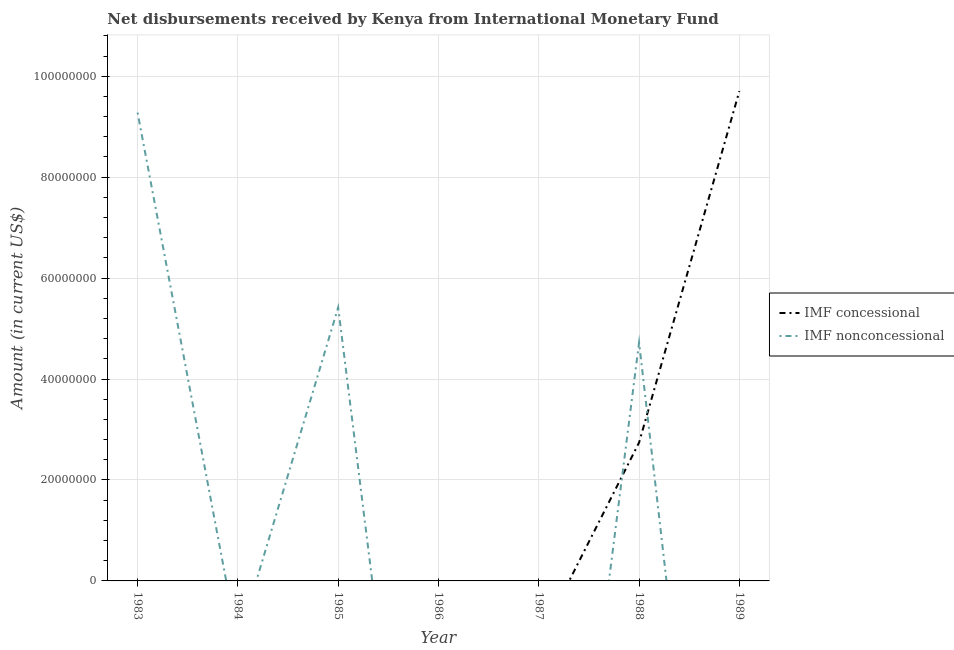What is the net concessional disbursements from imf in 1989?
Give a very brief answer. 9.71e+07. Across all years, what is the maximum net non concessional disbursements from imf?
Your answer should be compact. 9.28e+07. Across all years, what is the minimum net concessional disbursements from imf?
Provide a short and direct response. 0. What is the total net concessional disbursements from imf in the graph?
Make the answer very short. 1.24e+08. What is the difference between the net concessional disbursements from imf in 1988 and that in 1989?
Ensure brevity in your answer.  -6.96e+07. What is the difference between the net non concessional disbursements from imf in 1987 and the net concessional disbursements from imf in 1985?
Offer a terse response. 0. What is the average net concessional disbursements from imf per year?
Provide a succinct answer. 1.78e+07. In how many years, is the net concessional disbursements from imf greater than 60000000 US$?
Give a very brief answer. 1. What is the ratio of the net non concessional disbursements from imf in 1985 to that in 1988?
Offer a very short reply. 1.15. What is the difference between the highest and the second highest net non concessional disbursements from imf?
Provide a succinct answer. 3.86e+07. What is the difference between the highest and the lowest net non concessional disbursements from imf?
Ensure brevity in your answer.  9.28e+07. In how many years, is the net non concessional disbursements from imf greater than the average net non concessional disbursements from imf taken over all years?
Provide a short and direct response. 3. Is the net non concessional disbursements from imf strictly greater than the net concessional disbursements from imf over the years?
Make the answer very short. No. What is the difference between two consecutive major ticks on the Y-axis?
Your answer should be very brief. 2.00e+07. Are the values on the major ticks of Y-axis written in scientific E-notation?
Offer a terse response. No. Where does the legend appear in the graph?
Your response must be concise. Center right. How are the legend labels stacked?
Give a very brief answer. Vertical. What is the title of the graph?
Provide a succinct answer. Net disbursements received by Kenya from International Monetary Fund. What is the label or title of the Y-axis?
Keep it short and to the point. Amount (in current US$). What is the Amount (in current US$) of IMF nonconcessional in 1983?
Offer a very short reply. 9.28e+07. What is the Amount (in current US$) of IMF concessional in 1984?
Provide a succinct answer. 0. What is the Amount (in current US$) in IMF nonconcessional in 1984?
Keep it short and to the point. 0. What is the Amount (in current US$) of IMF nonconcessional in 1985?
Keep it short and to the point. 5.42e+07. What is the Amount (in current US$) in IMF nonconcessional in 1986?
Keep it short and to the point. 0. What is the Amount (in current US$) of IMF concessional in 1987?
Provide a succinct answer. 0. What is the Amount (in current US$) of IMF nonconcessional in 1987?
Keep it short and to the point. 0. What is the Amount (in current US$) in IMF concessional in 1988?
Offer a terse response. 2.74e+07. What is the Amount (in current US$) of IMF nonconcessional in 1988?
Give a very brief answer. 4.73e+07. What is the Amount (in current US$) in IMF concessional in 1989?
Give a very brief answer. 9.71e+07. What is the Amount (in current US$) in IMF nonconcessional in 1989?
Your answer should be very brief. 0. Across all years, what is the maximum Amount (in current US$) of IMF concessional?
Your answer should be very brief. 9.71e+07. Across all years, what is the maximum Amount (in current US$) of IMF nonconcessional?
Your response must be concise. 9.28e+07. Across all years, what is the minimum Amount (in current US$) of IMF concessional?
Keep it short and to the point. 0. Across all years, what is the minimum Amount (in current US$) in IMF nonconcessional?
Provide a short and direct response. 0. What is the total Amount (in current US$) in IMF concessional in the graph?
Ensure brevity in your answer.  1.24e+08. What is the total Amount (in current US$) in IMF nonconcessional in the graph?
Your response must be concise. 1.94e+08. What is the difference between the Amount (in current US$) in IMF nonconcessional in 1983 and that in 1985?
Keep it short and to the point. 3.86e+07. What is the difference between the Amount (in current US$) of IMF nonconcessional in 1983 and that in 1988?
Your response must be concise. 4.55e+07. What is the difference between the Amount (in current US$) of IMF nonconcessional in 1985 and that in 1988?
Make the answer very short. 6.94e+06. What is the difference between the Amount (in current US$) of IMF concessional in 1988 and that in 1989?
Offer a terse response. -6.96e+07. What is the average Amount (in current US$) of IMF concessional per year?
Offer a terse response. 1.78e+07. What is the average Amount (in current US$) of IMF nonconcessional per year?
Your response must be concise. 2.78e+07. In the year 1988, what is the difference between the Amount (in current US$) of IMF concessional and Amount (in current US$) of IMF nonconcessional?
Offer a very short reply. -1.98e+07. What is the ratio of the Amount (in current US$) in IMF nonconcessional in 1983 to that in 1985?
Offer a terse response. 1.71. What is the ratio of the Amount (in current US$) of IMF nonconcessional in 1983 to that in 1988?
Provide a short and direct response. 1.96. What is the ratio of the Amount (in current US$) of IMF nonconcessional in 1985 to that in 1988?
Your answer should be compact. 1.15. What is the ratio of the Amount (in current US$) in IMF concessional in 1988 to that in 1989?
Ensure brevity in your answer.  0.28. What is the difference between the highest and the second highest Amount (in current US$) of IMF nonconcessional?
Give a very brief answer. 3.86e+07. What is the difference between the highest and the lowest Amount (in current US$) of IMF concessional?
Offer a terse response. 9.71e+07. What is the difference between the highest and the lowest Amount (in current US$) in IMF nonconcessional?
Offer a terse response. 9.28e+07. 